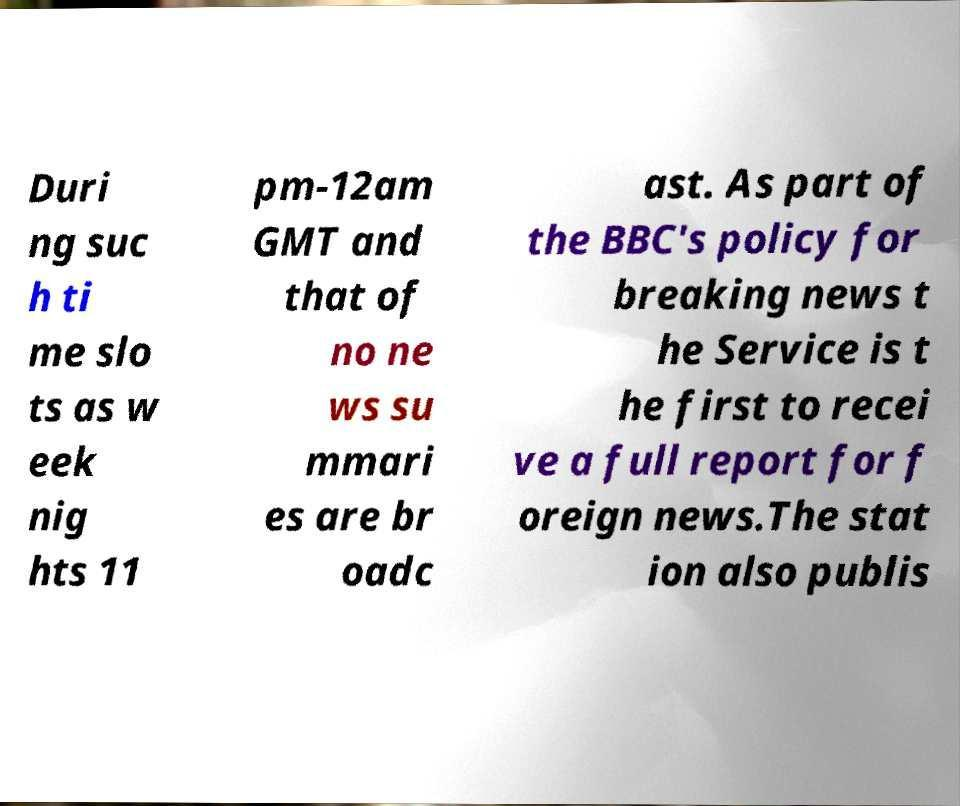There's text embedded in this image that I need extracted. Can you transcribe it verbatim? Duri ng suc h ti me slo ts as w eek nig hts 11 pm-12am GMT and that of no ne ws su mmari es are br oadc ast. As part of the BBC's policy for breaking news t he Service is t he first to recei ve a full report for f oreign news.The stat ion also publis 